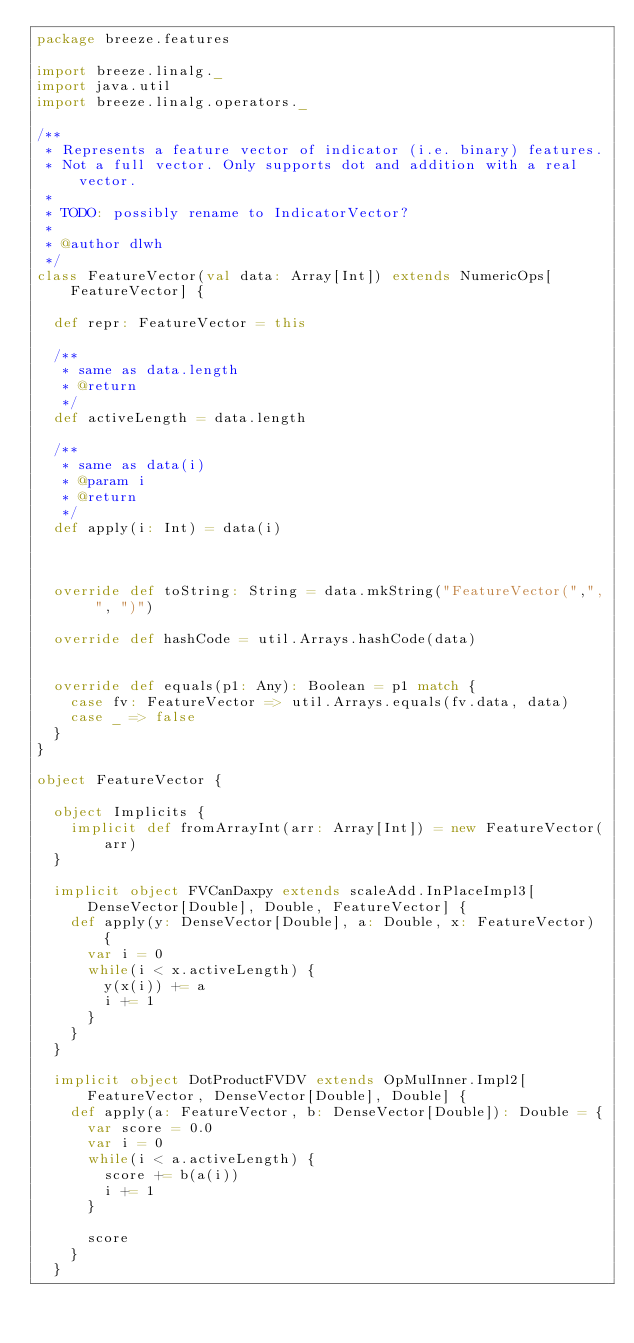<code> <loc_0><loc_0><loc_500><loc_500><_Scala_>package breeze.features

import breeze.linalg._
import java.util
import breeze.linalg.operators._

/**
 * Represents a feature vector of indicator (i.e. binary) features.
 * Not a full vector. Only supports dot and addition with a real vector.
 *
 * TODO: possibly rename to IndicatorVector?
 *
 * @author dlwh
 */
class FeatureVector(val data: Array[Int]) extends NumericOps[FeatureVector] {

  def repr: FeatureVector = this

  /**
   * same as data.length
   * @return
   */
  def activeLength = data.length

  /**
   * same as data(i)
   * @param i
   * @return
   */
  def apply(i: Int) = data(i)



  override def toString: String = data.mkString("FeatureVector(",", ", ")")

  override def hashCode = util.Arrays.hashCode(data)


  override def equals(p1: Any): Boolean = p1 match {
    case fv: FeatureVector => util.Arrays.equals(fv.data, data)
    case _ => false
  }
}

object FeatureVector {

  object Implicits {
    implicit def fromArrayInt(arr: Array[Int]) = new FeatureVector(arr)
  }

  implicit object FVCanDaxpy extends scaleAdd.InPlaceImpl3[DenseVector[Double], Double, FeatureVector] {
    def apply(y: DenseVector[Double], a: Double, x: FeatureVector) {
      var i = 0
      while(i < x.activeLength) {
        y(x(i)) += a
        i += 1
      }
    }
  }

  implicit object DotProductFVDV extends OpMulInner.Impl2[FeatureVector, DenseVector[Double], Double] {
    def apply(a: FeatureVector, b: DenseVector[Double]): Double = {
      var score = 0.0
      var i = 0
      while(i < a.activeLength) {
        score += b(a(i))
        i += 1
      }

      score
    }
  }
</code> 